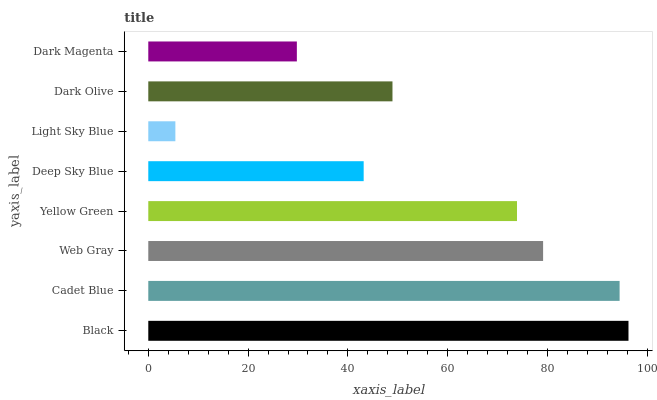Is Light Sky Blue the minimum?
Answer yes or no. Yes. Is Black the maximum?
Answer yes or no. Yes. Is Cadet Blue the minimum?
Answer yes or no. No. Is Cadet Blue the maximum?
Answer yes or no. No. Is Black greater than Cadet Blue?
Answer yes or no. Yes. Is Cadet Blue less than Black?
Answer yes or no. Yes. Is Cadet Blue greater than Black?
Answer yes or no. No. Is Black less than Cadet Blue?
Answer yes or no. No. Is Yellow Green the high median?
Answer yes or no. Yes. Is Dark Olive the low median?
Answer yes or no. Yes. Is Web Gray the high median?
Answer yes or no. No. Is Light Sky Blue the low median?
Answer yes or no. No. 